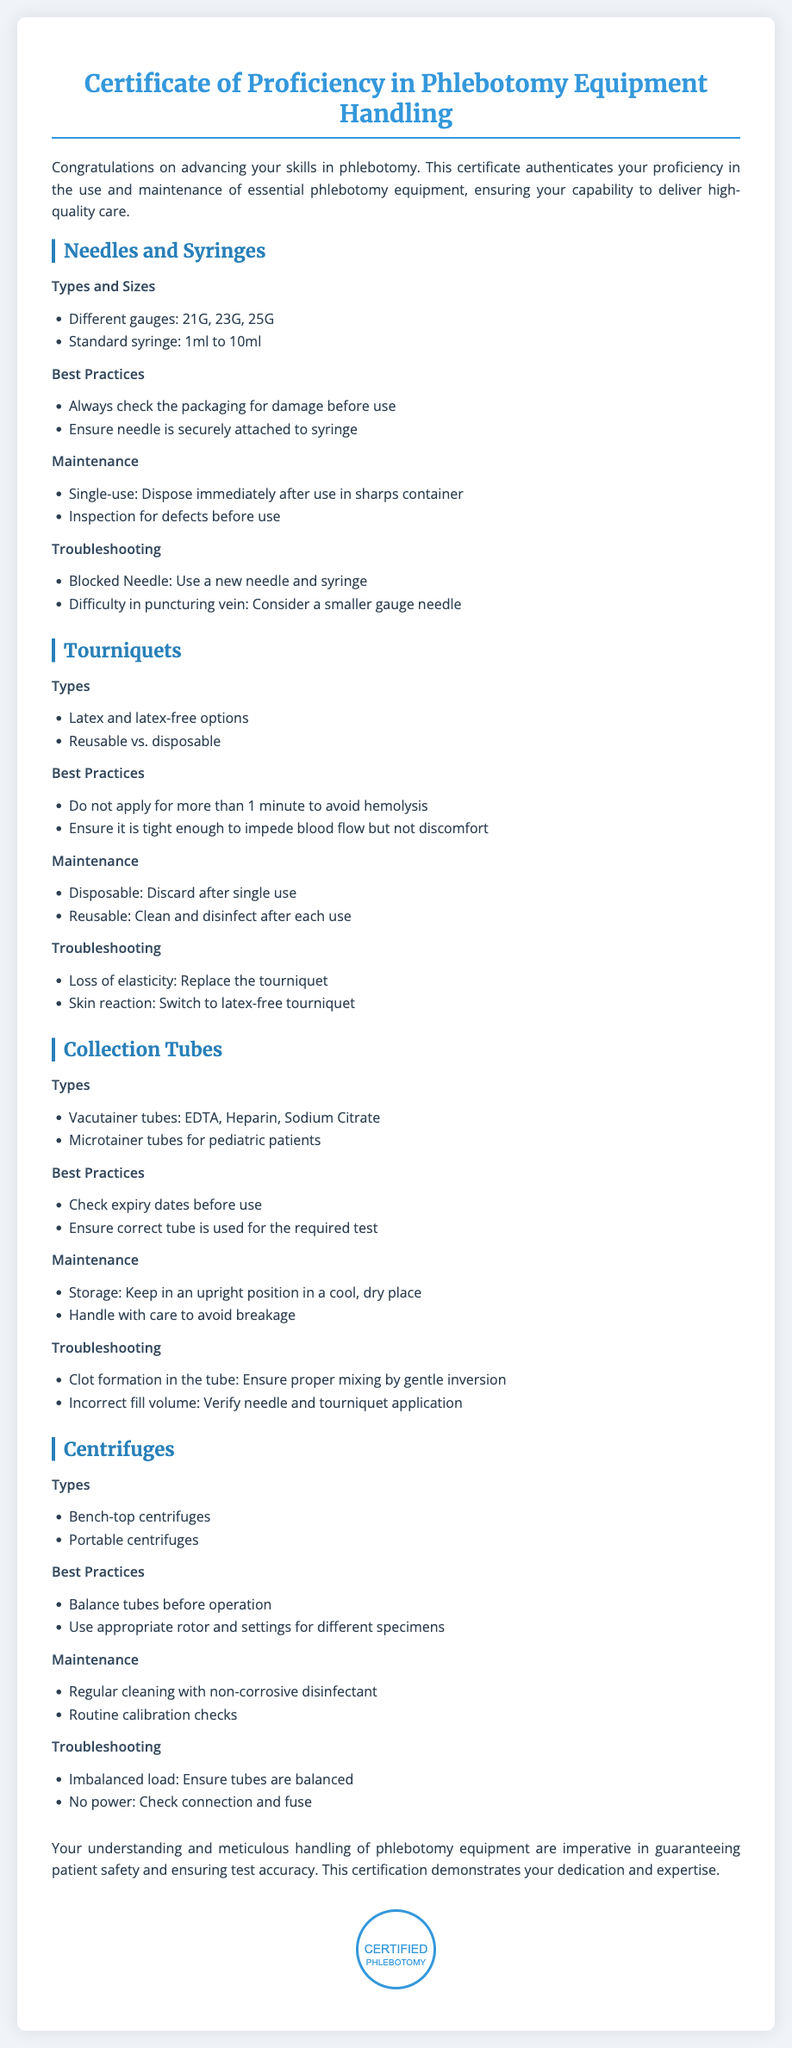what is the title of the certificate? The title of the certificate is displayed prominently at the top of the document.
Answer: Certificate of Proficiency in Phlebotomy Equipment Handling how many types of needles are mentioned? The document lists different gauge sizes of needles.
Answer: Three what should you check before using a needle? The document advises to check the packaging for any damage.
Answer: Packaging for damage how long should a tourniquet be applied? The best practice for tourniquet application states the maximum time it should be applied.
Answer: One minute name one type of collection tube mentioned. The document refers to specific types of collection tubes used in phlebotomy.
Answer: EDTA what is one maintenance tip for reusable tourniquets? The document provides guidance on cleaning and disinfecting reusable equipment.
Answer: Clean and disinfect what is one common issue with centrifuges? The troubleshooting section mentions common issues related to centrifuges.
Answer: Imbalanced load what does this certification demonstrate? The conclusion summarizes the significance of the certificate for the holder.
Answer: Dedication and expertise 